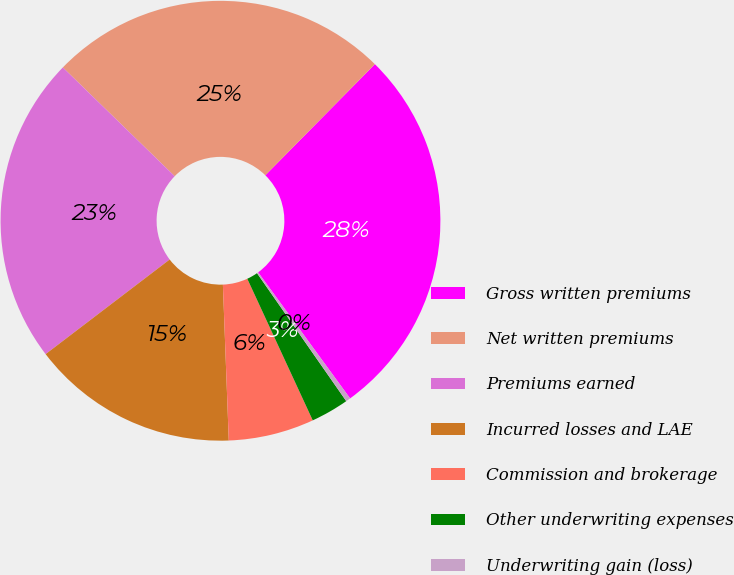Convert chart. <chart><loc_0><loc_0><loc_500><loc_500><pie_chart><fcel>Gross written premiums<fcel>Net written premiums<fcel>Premiums earned<fcel>Incurred losses and LAE<fcel>Commission and brokerage<fcel>Other underwriting expenses<fcel>Underwriting gain (loss)<nl><fcel>27.58%<fcel>25.11%<fcel>22.65%<fcel>15.23%<fcel>6.29%<fcel>2.8%<fcel>0.34%<nl></chart> 